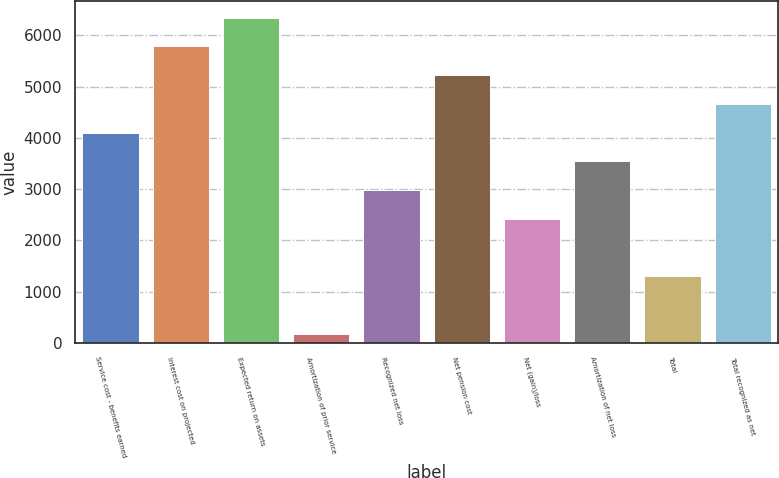Convert chart. <chart><loc_0><loc_0><loc_500><loc_500><bar_chart><fcel>Service cost - benefits earned<fcel>Interest cost on projected<fcel>Expected return on assets<fcel>Amortization of prior service<fcel>Recognized net loss<fcel>Net pension cost<fcel>Net (gain)/loss<fcel>Amortization of net loss<fcel>Total<fcel>Total recognized as net<nl><fcel>4103.6<fcel>5786<fcel>6346.8<fcel>178<fcel>2982<fcel>5225.2<fcel>2421.2<fcel>3542.8<fcel>1299.6<fcel>4664.4<nl></chart> 